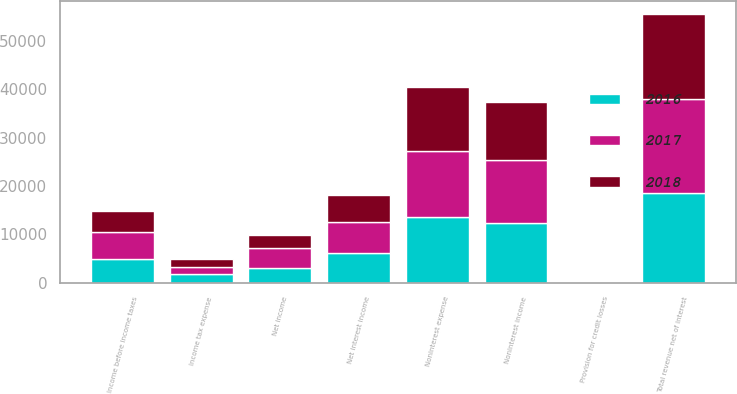<chart> <loc_0><loc_0><loc_500><loc_500><stacked_bar_chart><ecel><fcel>Net interest income<fcel>Noninterest income<fcel>Total revenue net of interest<fcel>Provision for credit losses<fcel>Noninterest expense<fcel>Income before income taxes<fcel>Income tax expense<fcel>Net income<nl><fcel>2017<fcel>6294<fcel>13044<fcel>19338<fcel>86<fcel>13777<fcel>5475<fcel>1396<fcel>4079<nl><fcel>2016<fcel>6173<fcel>12417<fcel>18590<fcel>56<fcel>13556<fcel>4978<fcel>1885<fcel>3093<nl><fcel>2018<fcel>5759<fcel>11891<fcel>17650<fcel>68<fcel>13166<fcel>4416<fcel>1635<fcel>2781<nl></chart> 